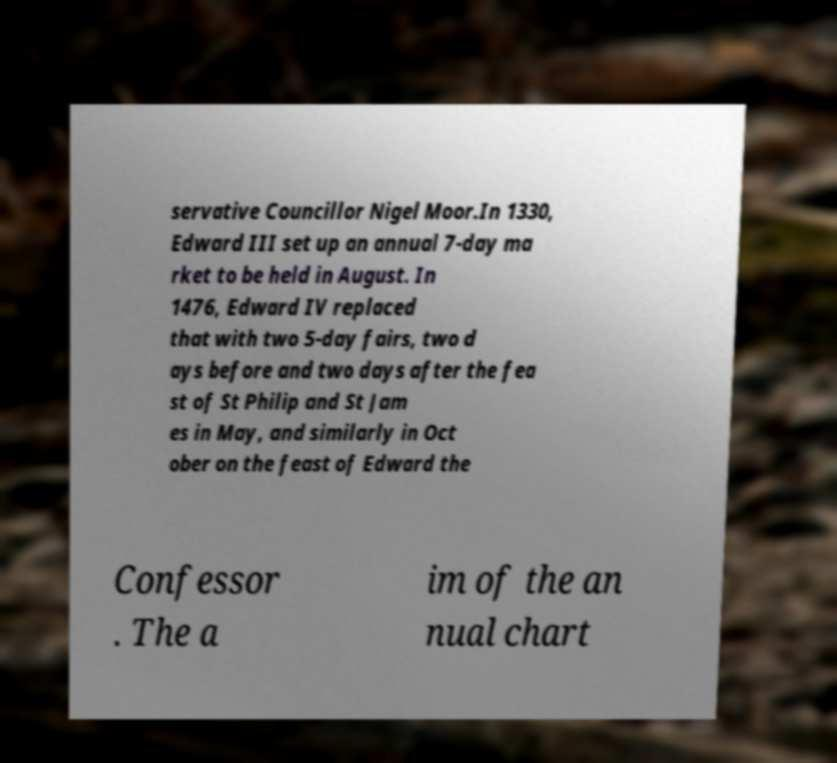I need the written content from this picture converted into text. Can you do that? servative Councillor Nigel Moor.In 1330, Edward III set up an annual 7-day ma rket to be held in August. In 1476, Edward IV replaced that with two 5-day fairs, two d ays before and two days after the fea st of St Philip and St Jam es in May, and similarly in Oct ober on the feast of Edward the Confessor . The a im of the an nual chart 